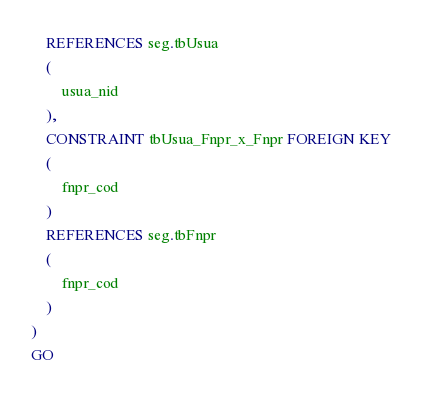Convert code to text. <code><loc_0><loc_0><loc_500><loc_500><_SQL_>	REFERENCES seg.tbUsua
	(
		usua_nid
	),
	CONSTRAINT tbUsua_Fnpr_x_Fnpr FOREIGN KEY
	(
		fnpr_cod
	)
	REFERENCES seg.tbFnpr
	(
		fnpr_cod
	)
)
GO
</code> 